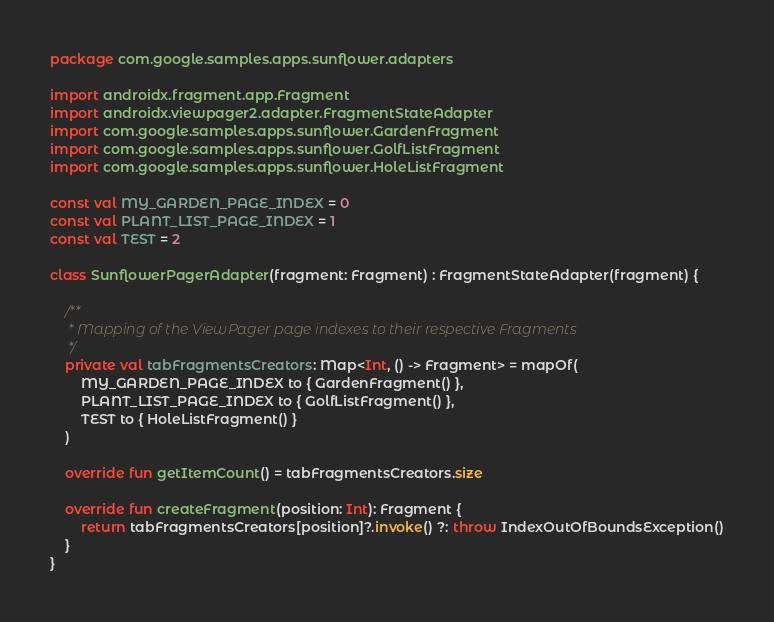Convert code to text. <code><loc_0><loc_0><loc_500><loc_500><_Kotlin_>package com.google.samples.apps.sunflower.adapters

import androidx.fragment.app.Fragment
import androidx.viewpager2.adapter.FragmentStateAdapter
import com.google.samples.apps.sunflower.GardenFragment
import com.google.samples.apps.sunflower.GolfListFragment
import com.google.samples.apps.sunflower.HoleListFragment

const val MY_GARDEN_PAGE_INDEX = 0
const val PLANT_LIST_PAGE_INDEX = 1
const val TEST = 2

class SunflowerPagerAdapter(fragment: Fragment) : FragmentStateAdapter(fragment) {

    /**
     * Mapping of the ViewPager page indexes to their respective Fragments
     */
    private val tabFragmentsCreators: Map<Int, () -> Fragment> = mapOf(
        MY_GARDEN_PAGE_INDEX to { GardenFragment() },
        PLANT_LIST_PAGE_INDEX to { GolfListFragment() },
        TEST to { HoleListFragment() }
    )

    override fun getItemCount() = tabFragmentsCreators.size

    override fun createFragment(position: Int): Fragment {
        return tabFragmentsCreators[position]?.invoke() ?: throw IndexOutOfBoundsException()
    }
}</code> 